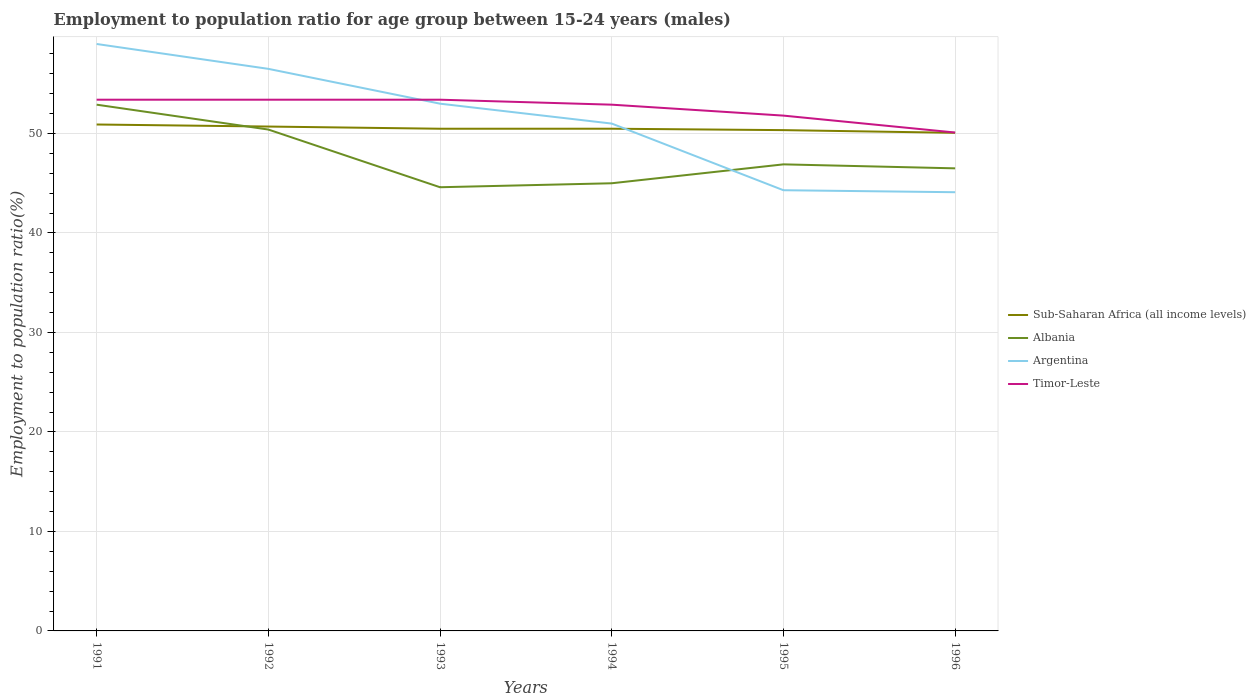Does the line corresponding to Argentina intersect with the line corresponding to Sub-Saharan Africa (all income levels)?
Your response must be concise. Yes. Across all years, what is the maximum employment to population ratio in Timor-Leste?
Offer a terse response. 50.1. What is the total employment to population ratio in Argentina in the graph?
Keep it short and to the point. 12.4. What is the difference between the highest and the second highest employment to population ratio in Timor-Leste?
Offer a very short reply. 3.3. How many lines are there?
Offer a very short reply. 4. What is the difference between two consecutive major ticks on the Y-axis?
Provide a succinct answer. 10. Are the values on the major ticks of Y-axis written in scientific E-notation?
Keep it short and to the point. No. Does the graph contain grids?
Offer a terse response. Yes. Where does the legend appear in the graph?
Provide a short and direct response. Center right. What is the title of the graph?
Ensure brevity in your answer.  Employment to population ratio for age group between 15-24 years (males). Does "Bahamas" appear as one of the legend labels in the graph?
Ensure brevity in your answer.  No. What is the label or title of the X-axis?
Give a very brief answer. Years. What is the label or title of the Y-axis?
Provide a succinct answer. Employment to population ratio(%). What is the Employment to population ratio(%) of Sub-Saharan Africa (all income levels) in 1991?
Offer a terse response. 50.91. What is the Employment to population ratio(%) of Albania in 1991?
Provide a short and direct response. 52.9. What is the Employment to population ratio(%) in Argentina in 1991?
Your answer should be very brief. 59. What is the Employment to population ratio(%) in Timor-Leste in 1991?
Provide a short and direct response. 53.4. What is the Employment to population ratio(%) of Sub-Saharan Africa (all income levels) in 1992?
Your answer should be very brief. 50.7. What is the Employment to population ratio(%) of Albania in 1992?
Your answer should be compact. 50.4. What is the Employment to population ratio(%) of Argentina in 1992?
Provide a succinct answer. 56.5. What is the Employment to population ratio(%) in Timor-Leste in 1992?
Your answer should be very brief. 53.4. What is the Employment to population ratio(%) in Sub-Saharan Africa (all income levels) in 1993?
Keep it short and to the point. 50.48. What is the Employment to population ratio(%) of Albania in 1993?
Your response must be concise. 44.6. What is the Employment to population ratio(%) of Timor-Leste in 1993?
Keep it short and to the point. 53.4. What is the Employment to population ratio(%) of Sub-Saharan Africa (all income levels) in 1994?
Your response must be concise. 50.48. What is the Employment to population ratio(%) in Albania in 1994?
Make the answer very short. 45. What is the Employment to population ratio(%) of Argentina in 1994?
Your answer should be compact. 51. What is the Employment to population ratio(%) of Timor-Leste in 1994?
Provide a succinct answer. 52.9. What is the Employment to population ratio(%) in Sub-Saharan Africa (all income levels) in 1995?
Your answer should be compact. 50.34. What is the Employment to population ratio(%) in Albania in 1995?
Offer a very short reply. 46.9. What is the Employment to population ratio(%) of Argentina in 1995?
Offer a very short reply. 44.3. What is the Employment to population ratio(%) of Timor-Leste in 1995?
Your answer should be very brief. 51.8. What is the Employment to population ratio(%) in Sub-Saharan Africa (all income levels) in 1996?
Your response must be concise. 50.07. What is the Employment to population ratio(%) of Albania in 1996?
Keep it short and to the point. 46.5. What is the Employment to population ratio(%) in Argentina in 1996?
Offer a very short reply. 44.1. What is the Employment to population ratio(%) of Timor-Leste in 1996?
Offer a very short reply. 50.1. Across all years, what is the maximum Employment to population ratio(%) in Sub-Saharan Africa (all income levels)?
Offer a terse response. 50.91. Across all years, what is the maximum Employment to population ratio(%) in Albania?
Give a very brief answer. 52.9. Across all years, what is the maximum Employment to population ratio(%) in Timor-Leste?
Make the answer very short. 53.4. Across all years, what is the minimum Employment to population ratio(%) of Sub-Saharan Africa (all income levels)?
Provide a short and direct response. 50.07. Across all years, what is the minimum Employment to population ratio(%) in Albania?
Your answer should be very brief. 44.6. Across all years, what is the minimum Employment to population ratio(%) in Argentina?
Keep it short and to the point. 44.1. Across all years, what is the minimum Employment to population ratio(%) in Timor-Leste?
Your answer should be very brief. 50.1. What is the total Employment to population ratio(%) in Sub-Saharan Africa (all income levels) in the graph?
Your response must be concise. 302.98. What is the total Employment to population ratio(%) in Albania in the graph?
Your answer should be very brief. 286.3. What is the total Employment to population ratio(%) in Argentina in the graph?
Make the answer very short. 307.9. What is the total Employment to population ratio(%) in Timor-Leste in the graph?
Offer a terse response. 315. What is the difference between the Employment to population ratio(%) of Sub-Saharan Africa (all income levels) in 1991 and that in 1992?
Offer a terse response. 0.21. What is the difference between the Employment to population ratio(%) of Argentina in 1991 and that in 1992?
Keep it short and to the point. 2.5. What is the difference between the Employment to population ratio(%) of Sub-Saharan Africa (all income levels) in 1991 and that in 1993?
Your answer should be compact. 0.43. What is the difference between the Employment to population ratio(%) in Albania in 1991 and that in 1993?
Keep it short and to the point. 8.3. What is the difference between the Employment to population ratio(%) in Argentina in 1991 and that in 1993?
Ensure brevity in your answer.  6. What is the difference between the Employment to population ratio(%) of Timor-Leste in 1991 and that in 1993?
Give a very brief answer. 0. What is the difference between the Employment to population ratio(%) of Sub-Saharan Africa (all income levels) in 1991 and that in 1994?
Your answer should be very brief. 0.42. What is the difference between the Employment to population ratio(%) in Argentina in 1991 and that in 1994?
Provide a short and direct response. 8. What is the difference between the Employment to population ratio(%) in Timor-Leste in 1991 and that in 1994?
Your answer should be very brief. 0.5. What is the difference between the Employment to population ratio(%) in Sub-Saharan Africa (all income levels) in 1991 and that in 1995?
Give a very brief answer. 0.57. What is the difference between the Employment to population ratio(%) of Argentina in 1991 and that in 1995?
Make the answer very short. 14.7. What is the difference between the Employment to population ratio(%) of Sub-Saharan Africa (all income levels) in 1991 and that in 1996?
Provide a short and direct response. 0.84. What is the difference between the Employment to population ratio(%) of Argentina in 1991 and that in 1996?
Make the answer very short. 14.9. What is the difference between the Employment to population ratio(%) of Timor-Leste in 1991 and that in 1996?
Provide a succinct answer. 3.3. What is the difference between the Employment to population ratio(%) of Sub-Saharan Africa (all income levels) in 1992 and that in 1993?
Your answer should be compact. 0.22. What is the difference between the Employment to population ratio(%) of Timor-Leste in 1992 and that in 1993?
Offer a very short reply. 0. What is the difference between the Employment to population ratio(%) of Sub-Saharan Africa (all income levels) in 1992 and that in 1994?
Your answer should be compact. 0.22. What is the difference between the Employment to population ratio(%) in Sub-Saharan Africa (all income levels) in 1992 and that in 1995?
Your response must be concise. 0.36. What is the difference between the Employment to population ratio(%) in Albania in 1992 and that in 1995?
Keep it short and to the point. 3.5. What is the difference between the Employment to population ratio(%) in Sub-Saharan Africa (all income levels) in 1992 and that in 1996?
Your answer should be very brief. 0.63. What is the difference between the Employment to population ratio(%) in Argentina in 1992 and that in 1996?
Make the answer very short. 12.4. What is the difference between the Employment to population ratio(%) of Timor-Leste in 1992 and that in 1996?
Keep it short and to the point. 3.3. What is the difference between the Employment to population ratio(%) of Sub-Saharan Africa (all income levels) in 1993 and that in 1994?
Your response must be concise. -0. What is the difference between the Employment to population ratio(%) in Albania in 1993 and that in 1994?
Provide a succinct answer. -0.4. What is the difference between the Employment to population ratio(%) in Timor-Leste in 1993 and that in 1994?
Your answer should be compact. 0.5. What is the difference between the Employment to population ratio(%) of Sub-Saharan Africa (all income levels) in 1993 and that in 1995?
Your response must be concise. 0.14. What is the difference between the Employment to population ratio(%) of Sub-Saharan Africa (all income levels) in 1993 and that in 1996?
Keep it short and to the point. 0.41. What is the difference between the Employment to population ratio(%) of Albania in 1993 and that in 1996?
Ensure brevity in your answer.  -1.9. What is the difference between the Employment to population ratio(%) of Argentina in 1993 and that in 1996?
Ensure brevity in your answer.  8.9. What is the difference between the Employment to population ratio(%) of Timor-Leste in 1993 and that in 1996?
Your answer should be compact. 3.3. What is the difference between the Employment to population ratio(%) of Sub-Saharan Africa (all income levels) in 1994 and that in 1995?
Your answer should be compact. 0.14. What is the difference between the Employment to population ratio(%) in Sub-Saharan Africa (all income levels) in 1994 and that in 1996?
Provide a succinct answer. 0.41. What is the difference between the Employment to population ratio(%) in Sub-Saharan Africa (all income levels) in 1995 and that in 1996?
Ensure brevity in your answer.  0.27. What is the difference between the Employment to population ratio(%) of Albania in 1995 and that in 1996?
Ensure brevity in your answer.  0.4. What is the difference between the Employment to population ratio(%) of Sub-Saharan Africa (all income levels) in 1991 and the Employment to population ratio(%) of Albania in 1992?
Offer a terse response. 0.51. What is the difference between the Employment to population ratio(%) in Sub-Saharan Africa (all income levels) in 1991 and the Employment to population ratio(%) in Argentina in 1992?
Make the answer very short. -5.59. What is the difference between the Employment to population ratio(%) of Sub-Saharan Africa (all income levels) in 1991 and the Employment to population ratio(%) of Timor-Leste in 1992?
Offer a very short reply. -2.49. What is the difference between the Employment to population ratio(%) of Albania in 1991 and the Employment to population ratio(%) of Argentina in 1992?
Provide a succinct answer. -3.6. What is the difference between the Employment to population ratio(%) of Argentina in 1991 and the Employment to population ratio(%) of Timor-Leste in 1992?
Offer a very short reply. 5.6. What is the difference between the Employment to population ratio(%) of Sub-Saharan Africa (all income levels) in 1991 and the Employment to population ratio(%) of Albania in 1993?
Provide a succinct answer. 6.31. What is the difference between the Employment to population ratio(%) in Sub-Saharan Africa (all income levels) in 1991 and the Employment to population ratio(%) in Argentina in 1993?
Your answer should be very brief. -2.09. What is the difference between the Employment to population ratio(%) of Sub-Saharan Africa (all income levels) in 1991 and the Employment to population ratio(%) of Timor-Leste in 1993?
Keep it short and to the point. -2.49. What is the difference between the Employment to population ratio(%) in Albania in 1991 and the Employment to population ratio(%) in Argentina in 1993?
Your response must be concise. -0.1. What is the difference between the Employment to population ratio(%) in Albania in 1991 and the Employment to population ratio(%) in Timor-Leste in 1993?
Give a very brief answer. -0.5. What is the difference between the Employment to population ratio(%) in Argentina in 1991 and the Employment to population ratio(%) in Timor-Leste in 1993?
Your answer should be compact. 5.6. What is the difference between the Employment to population ratio(%) of Sub-Saharan Africa (all income levels) in 1991 and the Employment to population ratio(%) of Albania in 1994?
Provide a short and direct response. 5.91. What is the difference between the Employment to population ratio(%) of Sub-Saharan Africa (all income levels) in 1991 and the Employment to population ratio(%) of Argentina in 1994?
Give a very brief answer. -0.09. What is the difference between the Employment to population ratio(%) in Sub-Saharan Africa (all income levels) in 1991 and the Employment to population ratio(%) in Timor-Leste in 1994?
Your answer should be compact. -1.99. What is the difference between the Employment to population ratio(%) of Argentina in 1991 and the Employment to population ratio(%) of Timor-Leste in 1994?
Provide a short and direct response. 6.1. What is the difference between the Employment to population ratio(%) of Sub-Saharan Africa (all income levels) in 1991 and the Employment to population ratio(%) of Albania in 1995?
Your response must be concise. 4.01. What is the difference between the Employment to population ratio(%) of Sub-Saharan Africa (all income levels) in 1991 and the Employment to population ratio(%) of Argentina in 1995?
Provide a short and direct response. 6.61. What is the difference between the Employment to population ratio(%) in Sub-Saharan Africa (all income levels) in 1991 and the Employment to population ratio(%) in Timor-Leste in 1995?
Keep it short and to the point. -0.89. What is the difference between the Employment to population ratio(%) of Albania in 1991 and the Employment to population ratio(%) of Timor-Leste in 1995?
Your answer should be compact. 1.1. What is the difference between the Employment to population ratio(%) in Sub-Saharan Africa (all income levels) in 1991 and the Employment to population ratio(%) in Albania in 1996?
Offer a terse response. 4.41. What is the difference between the Employment to population ratio(%) of Sub-Saharan Africa (all income levels) in 1991 and the Employment to population ratio(%) of Argentina in 1996?
Provide a succinct answer. 6.81. What is the difference between the Employment to population ratio(%) in Sub-Saharan Africa (all income levels) in 1991 and the Employment to population ratio(%) in Timor-Leste in 1996?
Your answer should be very brief. 0.81. What is the difference between the Employment to population ratio(%) of Albania in 1991 and the Employment to population ratio(%) of Argentina in 1996?
Give a very brief answer. 8.8. What is the difference between the Employment to population ratio(%) in Argentina in 1991 and the Employment to population ratio(%) in Timor-Leste in 1996?
Give a very brief answer. 8.9. What is the difference between the Employment to population ratio(%) of Sub-Saharan Africa (all income levels) in 1992 and the Employment to population ratio(%) of Albania in 1993?
Your answer should be compact. 6.1. What is the difference between the Employment to population ratio(%) in Sub-Saharan Africa (all income levels) in 1992 and the Employment to population ratio(%) in Argentina in 1993?
Provide a succinct answer. -2.3. What is the difference between the Employment to population ratio(%) of Sub-Saharan Africa (all income levels) in 1992 and the Employment to population ratio(%) of Timor-Leste in 1993?
Ensure brevity in your answer.  -2.7. What is the difference between the Employment to population ratio(%) of Sub-Saharan Africa (all income levels) in 1992 and the Employment to population ratio(%) of Albania in 1994?
Give a very brief answer. 5.7. What is the difference between the Employment to population ratio(%) of Sub-Saharan Africa (all income levels) in 1992 and the Employment to population ratio(%) of Argentina in 1994?
Provide a short and direct response. -0.3. What is the difference between the Employment to population ratio(%) of Sub-Saharan Africa (all income levels) in 1992 and the Employment to population ratio(%) of Timor-Leste in 1994?
Ensure brevity in your answer.  -2.2. What is the difference between the Employment to population ratio(%) in Albania in 1992 and the Employment to population ratio(%) in Argentina in 1994?
Your response must be concise. -0.6. What is the difference between the Employment to population ratio(%) of Sub-Saharan Africa (all income levels) in 1992 and the Employment to population ratio(%) of Albania in 1995?
Keep it short and to the point. 3.8. What is the difference between the Employment to population ratio(%) of Sub-Saharan Africa (all income levels) in 1992 and the Employment to population ratio(%) of Argentina in 1995?
Provide a succinct answer. 6.4. What is the difference between the Employment to population ratio(%) of Sub-Saharan Africa (all income levels) in 1992 and the Employment to population ratio(%) of Timor-Leste in 1995?
Your answer should be very brief. -1.1. What is the difference between the Employment to population ratio(%) in Albania in 1992 and the Employment to population ratio(%) in Argentina in 1995?
Provide a succinct answer. 6.1. What is the difference between the Employment to population ratio(%) in Albania in 1992 and the Employment to population ratio(%) in Timor-Leste in 1995?
Your response must be concise. -1.4. What is the difference between the Employment to population ratio(%) in Argentina in 1992 and the Employment to population ratio(%) in Timor-Leste in 1995?
Your answer should be compact. 4.7. What is the difference between the Employment to population ratio(%) of Sub-Saharan Africa (all income levels) in 1992 and the Employment to population ratio(%) of Albania in 1996?
Keep it short and to the point. 4.2. What is the difference between the Employment to population ratio(%) of Sub-Saharan Africa (all income levels) in 1992 and the Employment to population ratio(%) of Argentina in 1996?
Make the answer very short. 6.6. What is the difference between the Employment to population ratio(%) in Sub-Saharan Africa (all income levels) in 1992 and the Employment to population ratio(%) in Timor-Leste in 1996?
Your response must be concise. 0.6. What is the difference between the Employment to population ratio(%) of Albania in 1992 and the Employment to population ratio(%) of Argentina in 1996?
Provide a succinct answer. 6.3. What is the difference between the Employment to population ratio(%) in Argentina in 1992 and the Employment to population ratio(%) in Timor-Leste in 1996?
Offer a very short reply. 6.4. What is the difference between the Employment to population ratio(%) in Sub-Saharan Africa (all income levels) in 1993 and the Employment to population ratio(%) in Albania in 1994?
Make the answer very short. 5.48. What is the difference between the Employment to population ratio(%) of Sub-Saharan Africa (all income levels) in 1993 and the Employment to population ratio(%) of Argentina in 1994?
Your response must be concise. -0.52. What is the difference between the Employment to population ratio(%) of Sub-Saharan Africa (all income levels) in 1993 and the Employment to population ratio(%) of Timor-Leste in 1994?
Keep it short and to the point. -2.42. What is the difference between the Employment to population ratio(%) in Sub-Saharan Africa (all income levels) in 1993 and the Employment to population ratio(%) in Albania in 1995?
Make the answer very short. 3.58. What is the difference between the Employment to population ratio(%) in Sub-Saharan Africa (all income levels) in 1993 and the Employment to population ratio(%) in Argentina in 1995?
Offer a terse response. 6.18. What is the difference between the Employment to population ratio(%) of Sub-Saharan Africa (all income levels) in 1993 and the Employment to population ratio(%) of Timor-Leste in 1995?
Provide a short and direct response. -1.32. What is the difference between the Employment to population ratio(%) in Albania in 1993 and the Employment to population ratio(%) in Argentina in 1995?
Make the answer very short. 0.3. What is the difference between the Employment to population ratio(%) in Argentina in 1993 and the Employment to population ratio(%) in Timor-Leste in 1995?
Offer a terse response. 1.2. What is the difference between the Employment to population ratio(%) of Sub-Saharan Africa (all income levels) in 1993 and the Employment to population ratio(%) of Albania in 1996?
Offer a very short reply. 3.98. What is the difference between the Employment to population ratio(%) of Sub-Saharan Africa (all income levels) in 1993 and the Employment to population ratio(%) of Argentina in 1996?
Offer a very short reply. 6.38. What is the difference between the Employment to population ratio(%) of Sub-Saharan Africa (all income levels) in 1993 and the Employment to population ratio(%) of Timor-Leste in 1996?
Offer a very short reply. 0.38. What is the difference between the Employment to population ratio(%) in Albania in 1993 and the Employment to population ratio(%) in Timor-Leste in 1996?
Give a very brief answer. -5.5. What is the difference between the Employment to population ratio(%) in Sub-Saharan Africa (all income levels) in 1994 and the Employment to population ratio(%) in Albania in 1995?
Keep it short and to the point. 3.58. What is the difference between the Employment to population ratio(%) of Sub-Saharan Africa (all income levels) in 1994 and the Employment to population ratio(%) of Argentina in 1995?
Keep it short and to the point. 6.18. What is the difference between the Employment to population ratio(%) in Sub-Saharan Africa (all income levels) in 1994 and the Employment to population ratio(%) in Timor-Leste in 1995?
Offer a very short reply. -1.32. What is the difference between the Employment to population ratio(%) of Albania in 1994 and the Employment to population ratio(%) of Argentina in 1995?
Offer a very short reply. 0.7. What is the difference between the Employment to population ratio(%) of Albania in 1994 and the Employment to population ratio(%) of Timor-Leste in 1995?
Your answer should be very brief. -6.8. What is the difference between the Employment to population ratio(%) of Argentina in 1994 and the Employment to population ratio(%) of Timor-Leste in 1995?
Ensure brevity in your answer.  -0.8. What is the difference between the Employment to population ratio(%) in Sub-Saharan Africa (all income levels) in 1994 and the Employment to population ratio(%) in Albania in 1996?
Provide a succinct answer. 3.98. What is the difference between the Employment to population ratio(%) in Sub-Saharan Africa (all income levels) in 1994 and the Employment to population ratio(%) in Argentina in 1996?
Your response must be concise. 6.38. What is the difference between the Employment to population ratio(%) in Sub-Saharan Africa (all income levels) in 1994 and the Employment to population ratio(%) in Timor-Leste in 1996?
Make the answer very short. 0.38. What is the difference between the Employment to population ratio(%) of Albania in 1994 and the Employment to population ratio(%) of Argentina in 1996?
Ensure brevity in your answer.  0.9. What is the difference between the Employment to population ratio(%) of Albania in 1994 and the Employment to population ratio(%) of Timor-Leste in 1996?
Your answer should be very brief. -5.1. What is the difference between the Employment to population ratio(%) of Argentina in 1994 and the Employment to population ratio(%) of Timor-Leste in 1996?
Provide a succinct answer. 0.9. What is the difference between the Employment to population ratio(%) of Sub-Saharan Africa (all income levels) in 1995 and the Employment to population ratio(%) of Albania in 1996?
Give a very brief answer. 3.84. What is the difference between the Employment to population ratio(%) in Sub-Saharan Africa (all income levels) in 1995 and the Employment to population ratio(%) in Argentina in 1996?
Keep it short and to the point. 6.24. What is the difference between the Employment to population ratio(%) in Sub-Saharan Africa (all income levels) in 1995 and the Employment to population ratio(%) in Timor-Leste in 1996?
Give a very brief answer. 0.24. What is the difference between the Employment to population ratio(%) of Albania in 1995 and the Employment to population ratio(%) of Argentina in 1996?
Your answer should be very brief. 2.8. What is the difference between the Employment to population ratio(%) of Albania in 1995 and the Employment to population ratio(%) of Timor-Leste in 1996?
Your response must be concise. -3.2. What is the average Employment to population ratio(%) of Sub-Saharan Africa (all income levels) per year?
Your answer should be very brief. 50.5. What is the average Employment to population ratio(%) in Albania per year?
Your answer should be compact. 47.72. What is the average Employment to population ratio(%) in Argentina per year?
Make the answer very short. 51.32. What is the average Employment to population ratio(%) in Timor-Leste per year?
Offer a very short reply. 52.5. In the year 1991, what is the difference between the Employment to population ratio(%) in Sub-Saharan Africa (all income levels) and Employment to population ratio(%) in Albania?
Offer a terse response. -1.99. In the year 1991, what is the difference between the Employment to population ratio(%) in Sub-Saharan Africa (all income levels) and Employment to population ratio(%) in Argentina?
Provide a succinct answer. -8.09. In the year 1991, what is the difference between the Employment to population ratio(%) of Sub-Saharan Africa (all income levels) and Employment to population ratio(%) of Timor-Leste?
Offer a terse response. -2.49. In the year 1991, what is the difference between the Employment to population ratio(%) in Albania and Employment to population ratio(%) in Argentina?
Offer a terse response. -6.1. In the year 1991, what is the difference between the Employment to population ratio(%) in Albania and Employment to population ratio(%) in Timor-Leste?
Offer a very short reply. -0.5. In the year 1992, what is the difference between the Employment to population ratio(%) in Sub-Saharan Africa (all income levels) and Employment to population ratio(%) in Albania?
Keep it short and to the point. 0.3. In the year 1992, what is the difference between the Employment to population ratio(%) of Sub-Saharan Africa (all income levels) and Employment to population ratio(%) of Argentina?
Offer a terse response. -5.8. In the year 1992, what is the difference between the Employment to population ratio(%) of Sub-Saharan Africa (all income levels) and Employment to population ratio(%) of Timor-Leste?
Make the answer very short. -2.7. In the year 1992, what is the difference between the Employment to population ratio(%) in Argentina and Employment to population ratio(%) in Timor-Leste?
Keep it short and to the point. 3.1. In the year 1993, what is the difference between the Employment to population ratio(%) in Sub-Saharan Africa (all income levels) and Employment to population ratio(%) in Albania?
Provide a short and direct response. 5.88. In the year 1993, what is the difference between the Employment to population ratio(%) of Sub-Saharan Africa (all income levels) and Employment to population ratio(%) of Argentina?
Give a very brief answer. -2.52. In the year 1993, what is the difference between the Employment to population ratio(%) of Sub-Saharan Africa (all income levels) and Employment to population ratio(%) of Timor-Leste?
Make the answer very short. -2.92. In the year 1993, what is the difference between the Employment to population ratio(%) of Argentina and Employment to population ratio(%) of Timor-Leste?
Offer a very short reply. -0.4. In the year 1994, what is the difference between the Employment to population ratio(%) in Sub-Saharan Africa (all income levels) and Employment to population ratio(%) in Albania?
Your response must be concise. 5.48. In the year 1994, what is the difference between the Employment to population ratio(%) in Sub-Saharan Africa (all income levels) and Employment to population ratio(%) in Argentina?
Make the answer very short. -0.52. In the year 1994, what is the difference between the Employment to population ratio(%) in Sub-Saharan Africa (all income levels) and Employment to population ratio(%) in Timor-Leste?
Provide a succinct answer. -2.42. In the year 1994, what is the difference between the Employment to population ratio(%) of Albania and Employment to population ratio(%) of Argentina?
Make the answer very short. -6. In the year 1994, what is the difference between the Employment to population ratio(%) of Albania and Employment to population ratio(%) of Timor-Leste?
Your answer should be compact. -7.9. In the year 1995, what is the difference between the Employment to population ratio(%) in Sub-Saharan Africa (all income levels) and Employment to population ratio(%) in Albania?
Provide a short and direct response. 3.44. In the year 1995, what is the difference between the Employment to population ratio(%) in Sub-Saharan Africa (all income levels) and Employment to population ratio(%) in Argentina?
Make the answer very short. 6.04. In the year 1995, what is the difference between the Employment to population ratio(%) in Sub-Saharan Africa (all income levels) and Employment to population ratio(%) in Timor-Leste?
Make the answer very short. -1.46. In the year 1995, what is the difference between the Employment to population ratio(%) in Albania and Employment to population ratio(%) in Argentina?
Provide a short and direct response. 2.6. In the year 1995, what is the difference between the Employment to population ratio(%) in Albania and Employment to population ratio(%) in Timor-Leste?
Give a very brief answer. -4.9. In the year 1995, what is the difference between the Employment to population ratio(%) of Argentina and Employment to population ratio(%) of Timor-Leste?
Provide a succinct answer. -7.5. In the year 1996, what is the difference between the Employment to population ratio(%) of Sub-Saharan Africa (all income levels) and Employment to population ratio(%) of Albania?
Offer a very short reply. 3.57. In the year 1996, what is the difference between the Employment to population ratio(%) in Sub-Saharan Africa (all income levels) and Employment to population ratio(%) in Argentina?
Your answer should be compact. 5.97. In the year 1996, what is the difference between the Employment to population ratio(%) in Sub-Saharan Africa (all income levels) and Employment to population ratio(%) in Timor-Leste?
Offer a terse response. -0.03. In the year 1996, what is the difference between the Employment to population ratio(%) of Argentina and Employment to population ratio(%) of Timor-Leste?
Your answer should be compact. -6. What is the ratio of the Employment to population ratio(%) in Sub-Saharan Africa (all income levels) in 1991 to that in 1992?
Keep it short and to the point. 1. What is the ratio of the Employment to population ratio(%) in Albania in 1991 to that in 1992?
Give a very brief answer. 1.05. What is the ratio of the Employment to population ratio(%) of Argentina in 1991 to that in 1992?
Offer a terse response. 1.04. What is the ratio of the Employment to population ratio(%) of Timor-Leste in 1991 to that in 1992?
Ensure brevity in your answer.  1. What is the ratio of the Employment to population ratio(%) in Sub-Saharan Africa (all income levels) in 1991 to that in 1993?
Your response must be concise. 1.01. What is the ratio of the Employment to population ratio(%) in Albania in 1991 to that in 1993?
Provide a short and direct response. 1.19. What is the ratio of the Employment to population ratio(%) of Argentina in 1991 to that in 1993?
Keep it short and to the point. 1.11. What is the ratio of the Employment to population ratio(%) of Timor-Leste in 1991 to that in 1993?
Offer a very short reply. 1. What is the ratio of the Employment to population ratio(%) in Sub-Saharan Africa (all income levels) in 1991 to that in 1994?
Give a very brief answer. 1.01. What is the ratio of the Employment to population ratio(%) of Albania in 1991 to that in 1994?
Make the answer very short. 1.18. What is the ratio of the Employment to population ratio(%) in Argentina in 1991 to that in 1994?
Offer a very short reply. 1.16. What is the ratio of the Employment to population ratio(%) in Timor-Leste in 1991 to that in 1994?
Give a very brief answer. 1.01. What is the ratio of the Employment to population ratio(%) in Sub-Saharan Africa (all income levels) in 1991 to that in 1995?
Provide a short and direct response. 1.01. What is the ratio of the Employment to population ratio(%) in Albania in 1991 to that in 1995?
Keep it short and to the point. 1.13. What is the ratio of the Employment to population ratio(%) in Argentina in 1991 to that in 1995?
Ensure brevity in your answer.  1.33. What is the ratio of the Employment to population ratio(%) of Timor-Leste in 1991 to that in 1995?
Ensure brevity in your answer.  1.03. What is the ratio of the Employment to population ratio(%) in Sub-Saharan Africa (all income levels) in 1991 to that in 1996?
Ensure brevity in your answer.  1.02. What is the ratio of the Employment to population ratio(%) in Albania in 1991 to that in 1996?
Offer a terse response. 1.14. What is the ratio of the Employment to population ratio(%) of Argentina in 1991 to that in 1996?
Offer a very short reply. 1.34. What is the ratio of the Employment to population ratio(%) in Timor-Leste in 1991 to that in 1996?
Your response must be concise. 1.07. What is the ratio of the Employment to population ratio(%) in Sub-Saharan Africa (all income levels) in 1992 to that in 1993?
Your answer should be very brief. 1. What is the ratio of the Employment to population ratio(%) in Albania in 1992 to that in 1993?
Keep it short and to the point. 1.13. What is the ratio of the Employment to population ratio(%) in Argentina in 1992 to that in 1993?
Your response must be concise. 1.07. What is the ratio of the Employment to population ratio(%) in Sub-Saharan Africa (all income levels) in 1992 to that in 1994?
Your response must be concise. 1. What is the ratio of the Employment to population ratio(%) of Albania in 1992 to that in 1994?
Provide a succinct answer. 1.12. What is the ratio of the Employment to population ratio(%) in Argentina in 1992 to that in 1994?
Make the answer very short. 1.11. What is the ratio of the Employment to population ratio(%) in Timor-Leste in 1992 to that in 1994?
Ensure brevity in your answer.  1.01. What is the ratio of the Employment to population ratio(%) in Sub-Saharan Africa (all income levels) in 1992 to that in 1995?
Offer a terse response. 1.01. What is the ratio of the Employment to population ratio(%) of Albania in 1992 to that in 1995?
Ensure brevity in your answer.  1.07. What is the ratio of the Employment to population ratio(%) in Argentina in 1992 to that in 1995?
Provide a short and direct response. 1.28. What is the ratio of the Employment to population ratio(%) of Timor-Leste in 1992 to that in 1995?
Offer a very short reply. 1.03. What is the ratio of the Employment to population ratio(%) in Sub-Saharan Africa (all income levels) in 1992 to that in 1996?
Your answer should be very brief. 1.01. What is the ratio of the Employment to population ratio(%) of Albania in 1992 to that in 1996?
Make the answer very short. 1.08. What is the ratio of the Employment to population ratio(%) of Argentina in 1992 to that in 1996?
Offer a terse response. 1.28. What is the ratio of the Employment to population ratio(%) in Timor-Leste in 1992 to that in 1996?
Provide a short and direct response. 1.07. What is the ratio of the Employment to population ratio(%) in Albania in 1993 to that in 1994?
Make the answer very short. 0.99. What is the ratio of the Employment to population ratio(%) in Argentina in 1993 to that in 1994?
Provide a succinct answer. 1.04. What is the ratio of the Employment to population ratio(%) in Timor-Leste in 1993 to that in 1994?
Offer a very short reply. 1.01. What is the ratio of the Employment to population ratio(%) in Sub-Saharan Africa (all income levels) in 1993 to that in 1995?
Keep it short and to the point. 1. What is the ratio of the Employment to population ratio(%) in Albania in 1993 to that in 1995?
Your response must be concise. 0.95. What is the ratio of the Employment to population ratio(%) in Argentina in 1993 to that in 1995?
Offer a terse response. 1.2. What is the ratio of the Employment to population ratio(%) in Timor-Leste in 1993 to that in 1995?
Keep it short and to the point. 1.03. What is the ratio of the Employment to population ratio(%) of Sub-Saharan Africa (all income levels) in 1993 to that in 1996?
Your answer should be very brief. 1.01. What is the ratio of the Employment to population ratio(%) in Albania in 1993 to that in 1996?
Keep it short and to the point. 0.96. What is the ratio of the Employment to population ratio(%) in Argentina in 1993 to that in 1996?
Your response must be concise. 1.2. What is the ratio of the Employment to population ratio(%) in Timor-Leste in 1993 to that in 1996?
Make the answer very short. 1.07. What is the ratio of the Employment to population ratio(%) in Sub-Saharan Africa (all income levels) in 1994 to that in 1995?
Provide a succinct answer. 1. What is the ratio of the Employment to population ratio(%) in Albania in 1994 to that in 1995?
Your answer should be compact. 0.96. What is the ratio of the Employment to population ratio(%) of Argentina in 1994 to that in 1995?
Your answer should be compact. 1.15. What is the ratio of the Employment to population ratio(%) of Timor-Leste in 1994 to that in 1995?
Make the answer very short. 1.02. What is the ratio of the Employment to population ratio(%) of Sub-Saharan Africa (all income levels) in 1994 to that in 1996?
Offer a terse response. 1.01. What is the ratio of the Employment to population ratio(%) in Albania in 1994 to that in 1996?
Your response must be concise. 0.97. What is the ratio of the Employment to population ratio(%) in Argentina in 1994 to that in 1996?
Ensure brevity in your answer.  1.16. What is the ratio of the Employment to population ratio(%) in Timor-Leste in 1994 to that in 1996?
Keep it short and to the point. 1.06. What is the ratio of the Employment to population ratio(%) in Sub-Saharan Africa (all income levels) in 1995 to that in 1996?
Provide a succinct answer. 1.01. What is the ratio of the Employment to population ratio(%) in Albania in 1995 to that in 1996?
Ensure brevity in your answer.  1.01. What is the ratio of the Employment to population ratio(%) of Timor-Leste in 1995 to that in 1996?
Your answer should be very brief. 1.03. What is the difference between the highest and the second highest Employment to population ratio(%) of Sub-Saharan Africa (all income levels)?
Offer a very short reply. 0.21. What is the difference between the highest and the second highest Employment to population ratio(%) of Argentina?
Keep it short and to the point. 2.5. What is the difference between the highest and the second highest Employment to population ratio(%) in Timor-Leste?
Keep it short and to the point. 0. What is the difference between the highest and the lowest Employment to population ratio(%) of Sub-Saharan Africa (all income levels)?
Ensure brevity in your answer.  0.84. What is the difference between the highest and the lowest Employment to population ratio(%) in Albania?
Make the answer very short. 8.3. What is the difference between the highest and the lowest Employment to population ratio(%) of Argentina?
Offer a very short reply. 14.9. What is the difference between the highest and the lowest Employment to population ratio(%) of Timor-Leste?
Offer a terse response. 3.3. 